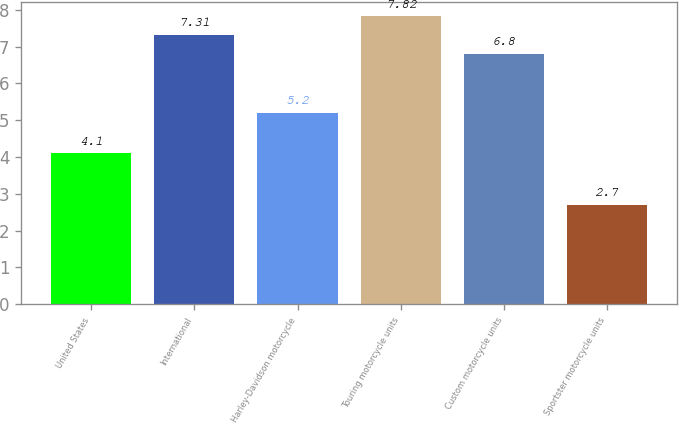Convert chart. <chart><loc_0><loc_0><loc_500><loc_500><bar_chart><fcel>United States<fcel>International<fcel>Harley-Davidson motorcycle<fcel>Touring motorcycle units<fcel>Custom motorcycle units<fcel>Sportster motorcycle units<nl><fcel>4.1<fcel>7.31<fcel>5.2<fcel>7.82<fcel>6.8<fcel>2.7<nl></chart> 